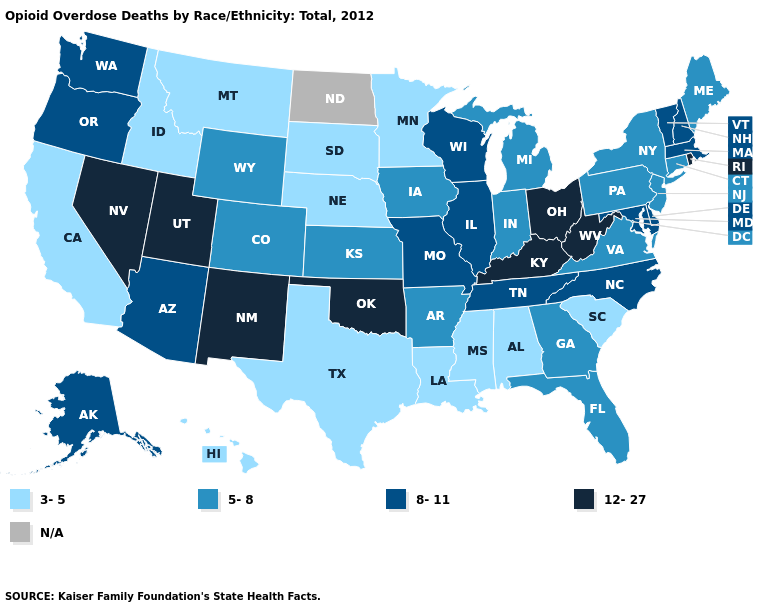What is the value of Iowa?
Concise answer only. 5-8. What is the highest value in states that border Colorado?
Answer briefly. 12-27. Does Ohio have the highest value in the USA?
Give a very brief answer. Yes. Name the states that have a value in the range 5-8?
Give a very brief answer. Arkansas, Colorado, Connecticut, Florida, Georgia, Indiana, Iowa, Kansas, Maine, Michigan, New Jersey, New York, Pennsylvania, Virginia, Wyoming. Does the map have missing data?
Short answer required. Yes. Among the states that border Wisconsin , which have the lowest value?
Keep it brief. Minnesota. What is the value of Missouri?
Keep it brief. 8-11. Does the first symbol in the legend represent the smallest category?
Answer briefly. Yes. Does the map have missing data?
Give a very brief answer. Yes. What is the value of Iowa?
Concise answer only. 5-8. Is the legend a continuous bar?
Short answer required. No. Does Nebraska have the lowest value in the MidWest?
Quick response, please. Yes. What is the lowest value in the South?
Be succinct. 3-5. How many symbols are there in the legend?
Short answer required. 5. 